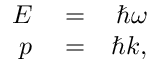<formula> <loc_0><loc_0><loc_500><loc_500>\begin{array} { r l r } { E } & = } & { \hbar { \omega } } \\ { p } & = } & { \hbar { k } , } \end{array}</formula> 